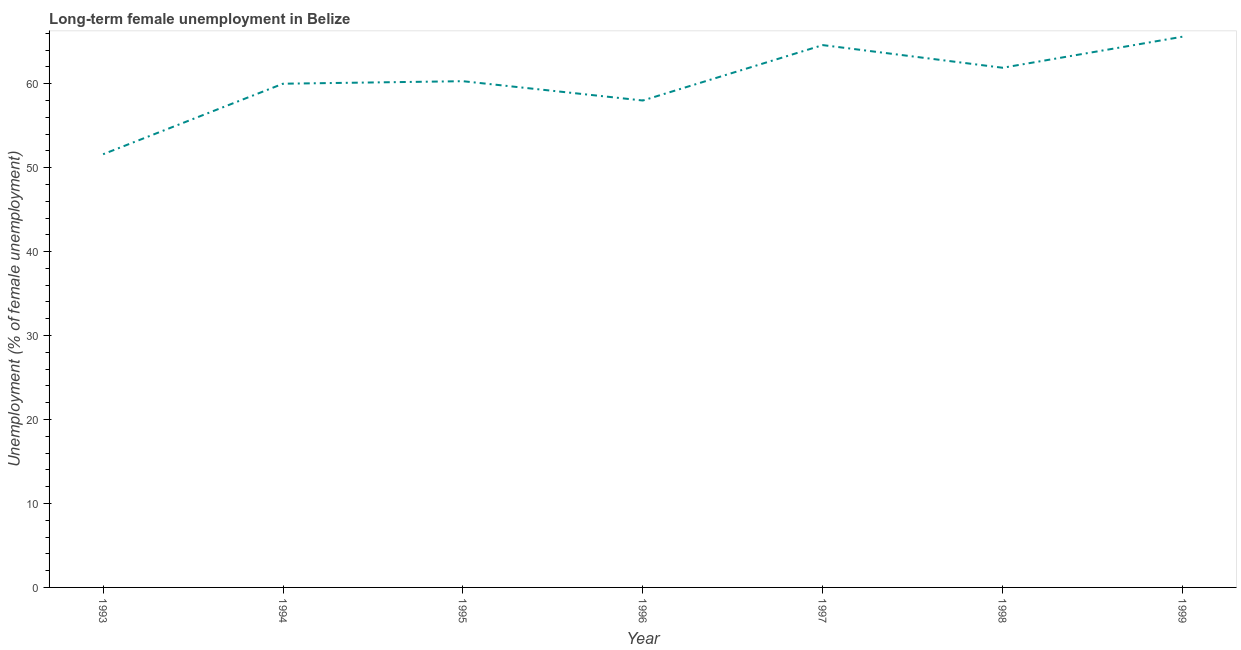What is the long-term female unemployment in 1999?
Offer a very short reply. 65.6. Across all years, what is the maximum long-term female unemployment?
Offer a terse response. 65.6. Across all years, what is the minimum long-term female unemployment?
Offer a very short reply. 51.6. In which year was the long-term female unemployment maximum?
Ensure brevity in your answer.  1999. In which year was the long-term female unemployment minimum?
Your answer should be very brief. 1993. What is the sum of the long-term female unemployment?
Your answer should be very brief. 422. What is the difference between the long-term female unemployment in 1996 and 1998?
Provide a succinct answer. -3.9. What is the average long-term female unemployment per year?
Provide a short and direct response. 60.29. What is the median long-term female unemployment?
Provide a succinct answer. 60.3. What is the ratio of the long-term female unemployment in 1993 to that in 1995?
Your response must be concise. 0.86. Is the difference between the long-term female unemployment in 1998 and 1999 greater than the difference between any two years?
Provide a succinct answer. No. Is the sum of the long-term female unemployment in 1995 and 1998 greater than the maximum long-term female unemployment across all years?
Keep it short and to the point. Yes. What is the difference between the highest and the lowest long-term female unemployment?
Give a very brief answer. 14. In how many years, is the long-term female unemployment greater than the average long-term female unemployment taken over all years?
Your response must be concise. 4. How many lines are there?
Offer a very short reply. 1. How many years are there in the graph?
Provide a short and direct response. 7. What is the difference between two consecutive major ticks on the Y-axis?
Your answer should be very brief. 10. Does the graph contain any zero values?
Make the answer very short. No. What is the title of the graph?
Provide a short and direct response. Long-term female unemployment in Belize. What is the label or title of the X-axis?
Offer a terse response. Year. What is the label or title of the Y-axis?
Make the answer very short. Unemployment (% of female unemployment). What is the Unemployment (% of female unemployment) of 1993?
Ensure brevity in your answer.  51.6. What is the Unemployment (% of female unemployment) of 1994?
Give a very brief answer. 60. What is the Unemployment (% of female unemployment) of 1995?
Make the answer very short. 60.3. What is the Unemployment (% of female unemployment) of 1996?
Your answer should be very brief. 58. What is the Unemployment (% of female unemployment) of 1997?
Offer a very short reply. 64.6. What is the Unemployment (% of female unemployment) of 1998?
Your response must be concise. 61.9. What is the Unemployment (% of female unemployment) of 1999?
Make the answer very short. 65.6. What is the difference between the Unemployment (% of female unemployment) in 1993 and 1994?
Ensure brevity in your answer.  -8.4. What is the difference between the Unemployment (% of female unemployment) in 1993 and 1996?
Give a very brief answer. -6.4. What is the difference between the Unemployment (% of female unemployment) in 1994 and 1995?
Give a very brief answer. -0.3. What is the difference between the Unemployment (% of female unemployment) in 1994 and 1996?
Offer a terse response. 2. What is the difference between the Unemployment (% of female unemployment) in 1994 and 1997?
Offer a very short reply. -4.6. What is the difference between the Unemployment (% of female unemployment) in 1994 and 1998?
Provide a succinct answer. -1.9. What is the difference between the Unemployment (% of female unemployment) in 1994 and 1999?
Offer a terse response. -5.6. What is the difference between the Unemployment (% of female unemployment) in 1995 and 1997?
Give a very brief answer. -4.3. What is the difference between the Unemployment (% of female unemployment) in 1996 and 1997?
Ensure brevity in your answer.  -6.6. What is the difference between the Unemployment (% of female unemployment) in 1997 and 1998?
Provide a short and direct response. 2.7. What is the difference between the Unemployment (% of female unemployment) in 1997 and 1999?
Provide a succinct answer. -1. What is the ratio of the Unemployment (% of female unemployment) in 1993 to that in 1994?
Provide a succinct answer. 0.86. What is the ratio of the Unemployment (% of female unemployment) in 1993 to that in 1995?
Your response must be concise. 0.86. What is the ratio of the Unemployment (% of female unemployment) in 1993 to that in 1996?
Provide a short and direct response. 0.89. What is the ratio of the Unemployment (% of female unemployment) in 1993 to that in 1997?
Ensure brevity in your answer.  0.8. What is the ratio of the Unemployment (% of female unemployment) in 1993 to that in 1998?
Provide a succinct answer. 0.83. What is the ratio of the Unemployment (% of female unemployment) in 1993 to that in 1999?
Give a very brief answer. 0.79. What is the ratio of the Unemployment (% of female unemployment) in 1994 to that in 1995?
Offer a very short reply. 0.99. What is the ratio of the Unemployment (% of female unemployment) in 1994 to that in 1996?
Give a very brief answer. 1.03. What is the ratio of the Unemployment (% of female unemployment) in 1994 to that in 1997?
Provide a short and direct response. 0.93. What is the ratio of the Unemployment (% of female unemployment) in 1994 to that in 1999?
Ensure brevity in your answer.  0.92. What is the ratio of the Unemployment (% of female unemployment) in 1995 to that in 1996?
Make the answer very short. 1.04. What is the ratio of the Unemployment (% of female unemployment) in 1995 to that in 1997?
Your response must be concise. 0.93. What is the ratio of the Unemployment (% of female unemployment) in 1995 to that in 1999?
Ensure brevity in your answer.  0.92. What is the ratio of the Unemployment (% of female unemployment) in 1996 to that in 1997?
Provide a succinct answer. 0.9. What is the ratio of the Unemployment (% of female unemployment) in 1996 to that in 1998?
Ensure brevity in your answer.  0.94. What is the ratio of the Unemployment (% of female unemployment) in 1996 to that in 1999?
Ensure brevity in your answer.  0.88. What is the ratio of the Unemployment (% of female unemployment) in 1997 to that in 1998?
Ensure brevity in your answer.  1.04. What is the ratio of the Unemployment (% of female unemployment) in 1997 to that in 1999?
Offer a terse response. 0.98. What is the ratio of the Unemployment (% of female unemployment) in 1998 to that in 1999?
Offer a very short reply. 0.94. 